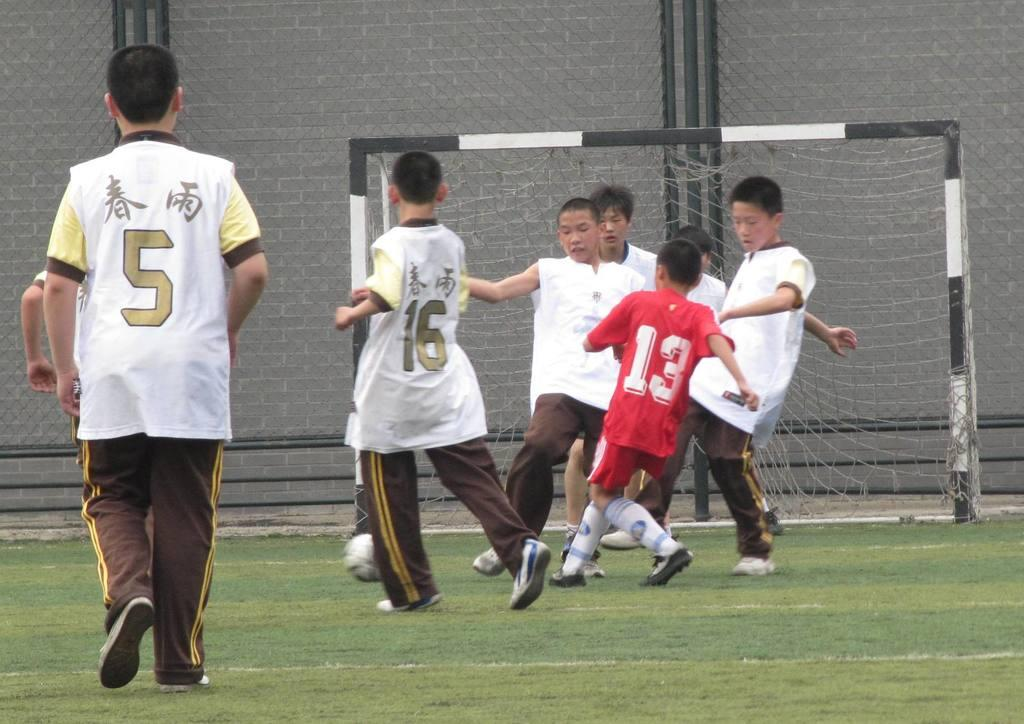<image>
Share a concise interpretation of the image provided. The only red player on the pitch is wearing number 13. 